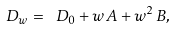<formula> <loc_0><loc_0><loc_500><loc_500>\ D _ { w } = \ D _ { 0 } + w \, A + w ^ { 2 } \, B ,</formula> 